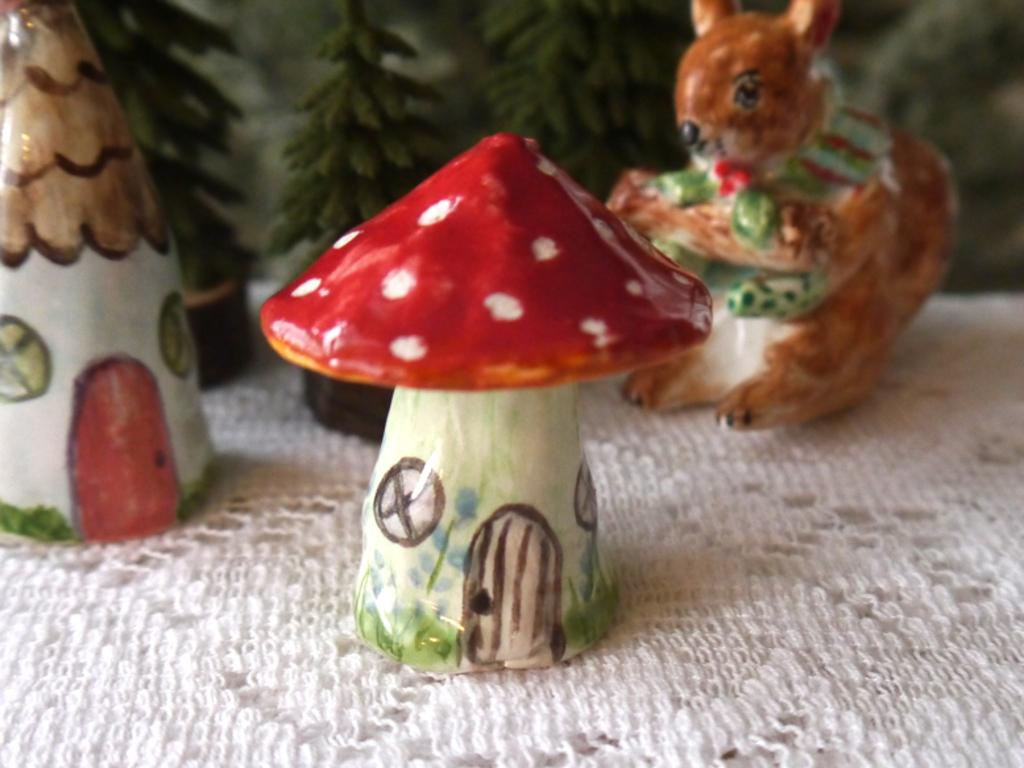What types of objects can be seen in the image? There are toys in the image. Can you describe the shape of one of the toys? One toy is in the shape of a mushroom. What is the shape of another toy in the image? Another toy is in the shape of an animal. What type of cow can be seen performing an act in the image? There is no cow or act present in the image; it features toys in the shape of a mushroom and an animal. 